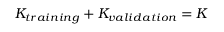<formula> <loc_0><loc_0><loc_500><loc_500>K _ { t r a i n i n g } + K _ { v a l i d a t i o n } = K</formula> 